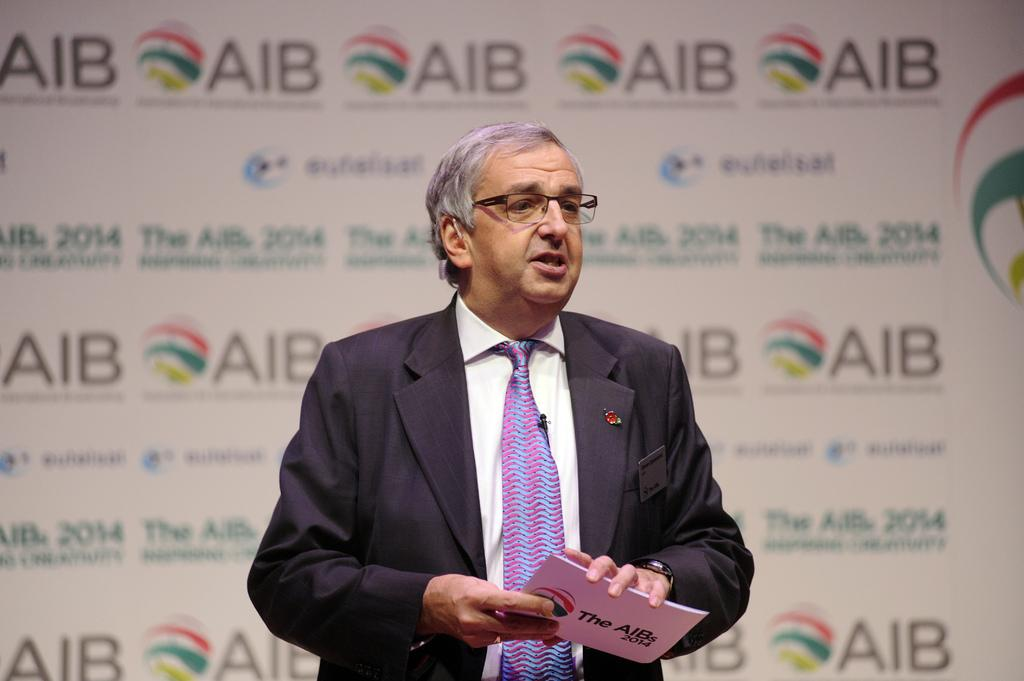What is the person in the image doing? The person in the image is holding a book. What else can be seen in the image besides the person? There is a banner in the image. What type of straw is the person using to read the book in the image? There is no straw present in the image, and the person is not using any straw to read the book. 